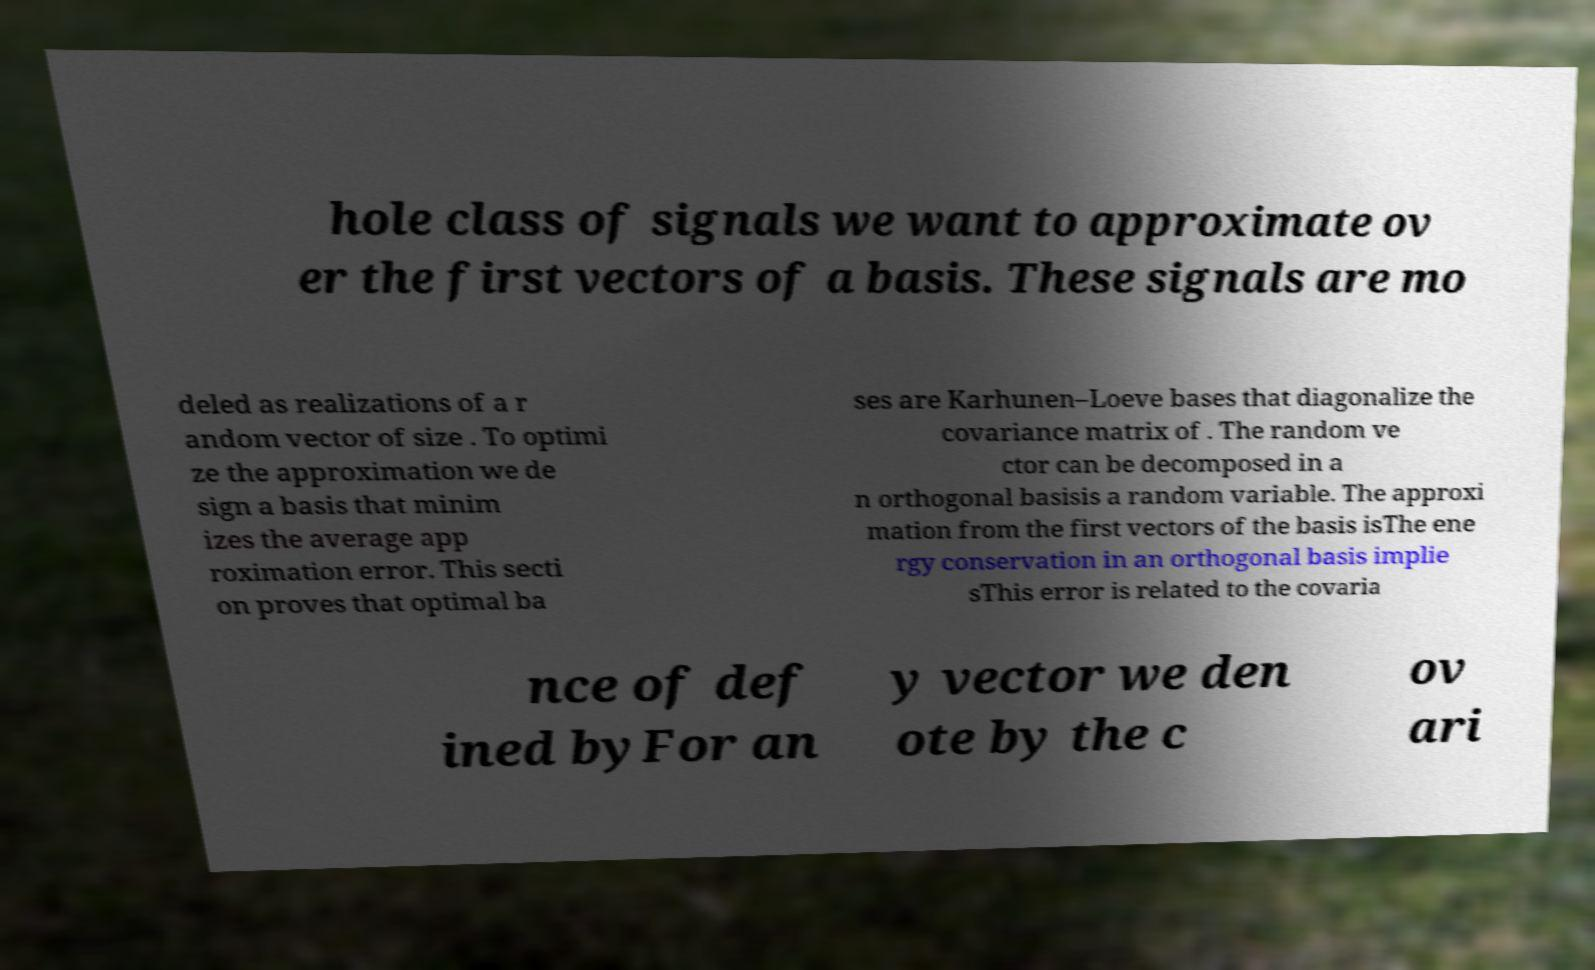Can you read and provide the text displayed in the image?This photo seems to have some interesting text. Can you extract and type it out for me? hole class of signals we want to approximate ov er the first vectors of a basis. These signals are mo deled as realizations of a r andom vector of size . To optimi ze the approximation we de sign a basis that minim izes the average app roximation error. This secti on proves that optimal ba ses are Karhunen–Loeve bases that diagonalize the covariance matrix of . The random ve ctor can be decomposed in a n orthogonal basisis a random variable. The approxi mation from the first vectors of the basis isThe ene rgy conservation in an orthogonal basis implie sThis error is related to the covaria nce of def ined byFor an y vector we den ote by the c ov ari 